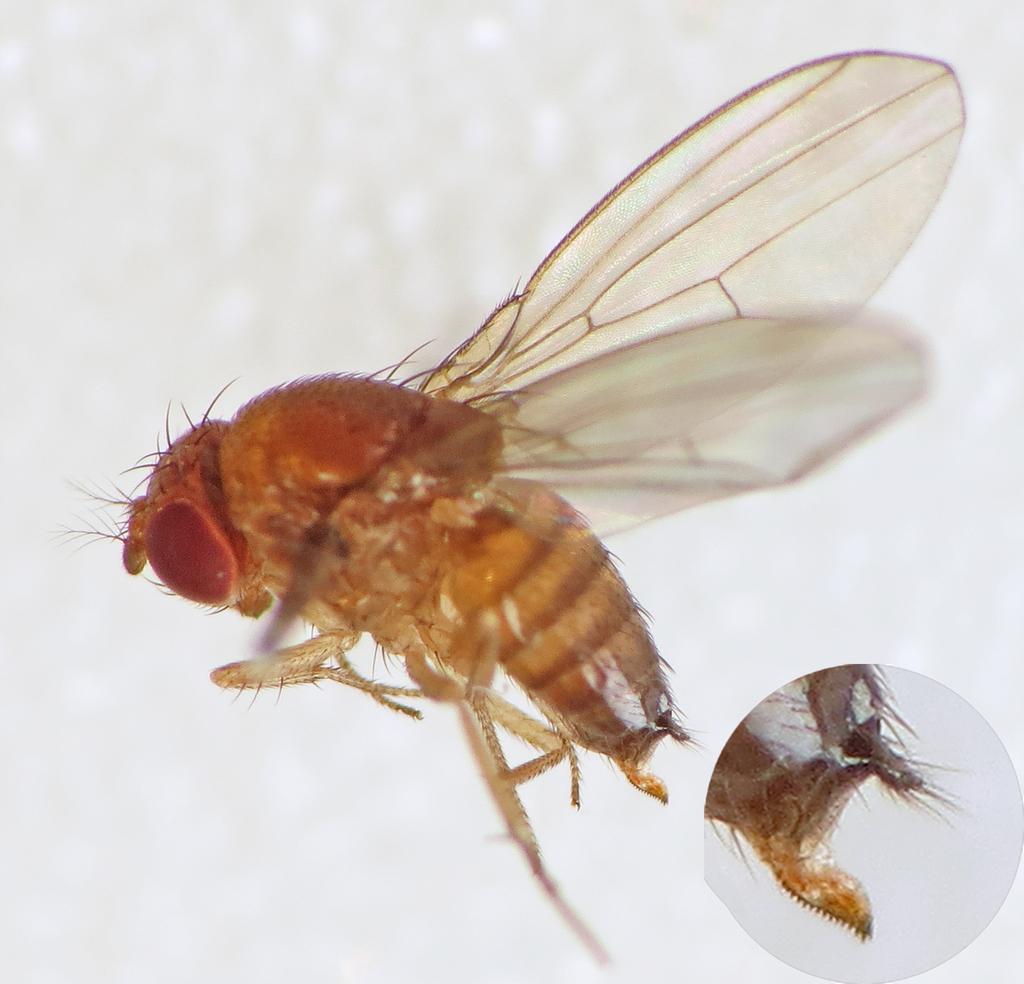Could you give a brief overview of what you see in this image? In this picture we can see an insect on the white background. We can see the back part of an insect in the bottom right. 